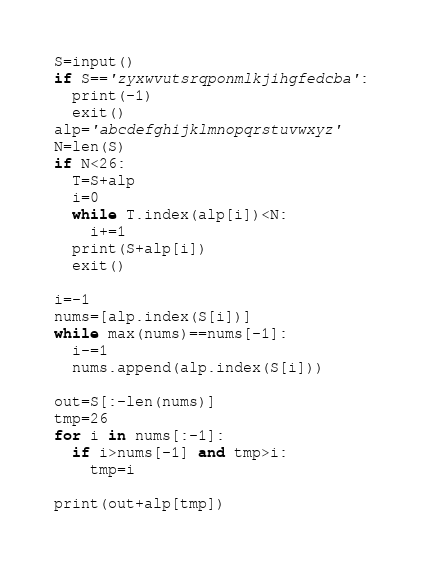Convert code to text. <code><loc_0><loc_0><loc_500><loc_500><_Python_>S=input()
if S=='zyxwvutsrqponmlkjihgfedcba':
  print(-1)
  exit()
alp='abcdefghijklmnopqrstuvwxyz'
N=len(S)
if N<26:
  T=S+alp
  i=0
  while T.index(alp[i])<N:
    i+=1
  print(S+alp[i])
  exit()
  
i=-1
nums=[alp.index(S[i])]
while max(nums)==nums[-1]:
  i-=1
  nums.append(alp.index(S[i]))

out=S[:-len(nums)]
tmp=26
for i in nums[:-1]:
  if i>nums[-1] and tmp>i:
    tmp=i
    
print(out+alp[tmp])</code> 